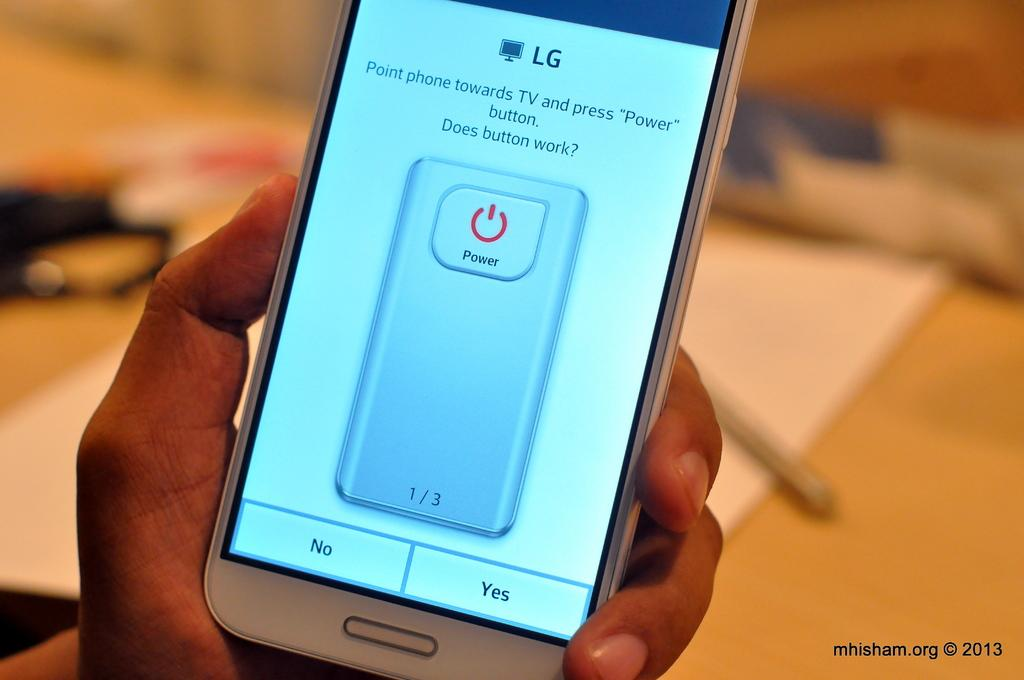Provide a one-sentence caption for the provided image. An LG brand phone offers instructions to link it to the TV. 